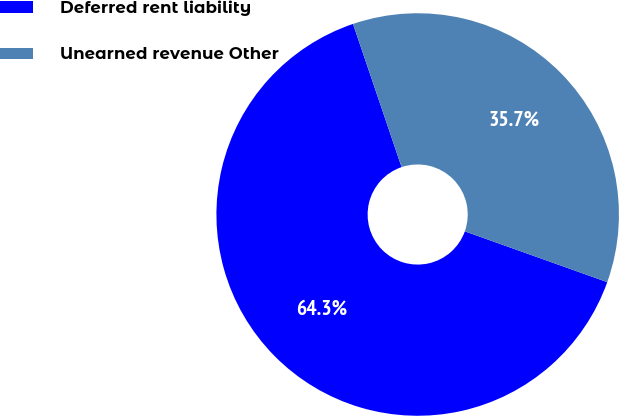Convert chart. <chart><loc_0><loc_0><loc_500><loc_500><pie_chart><fcel>Deferred rent liability<fcel>Unearned revenue Other<nl><fcel>64.34%<fcel>35.66%<nl></chart> 